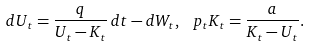<formula> <loc_0><loc_0><loc_500><loc_500>d U _ { t } = \frac { q } { U _ { t } - K _ { t } } \, d t - d W _ { t } , \, \ p _ { t } K _ { t } = \frac { a } { K _ { t } - U _ { t } } .</formula> 